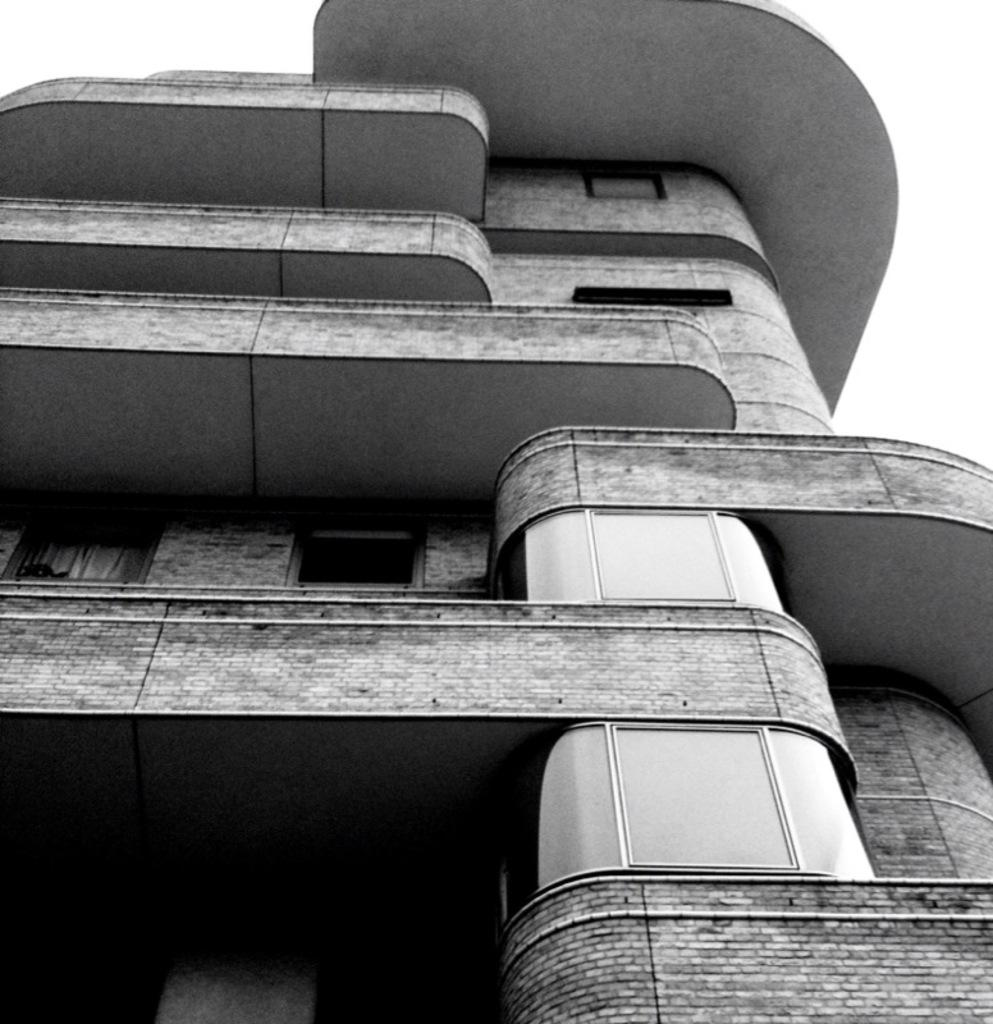What is the color scheme of the image? The image is black and white. What type of structure can be seen in the image? There is a building in the image. What type of pen is being used to write on the paper in the image? There is no pen or paper present in the image; it only features a building in a black and white color scheme. 